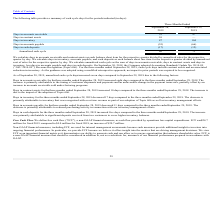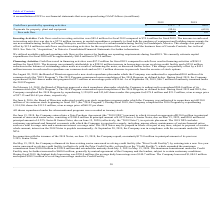According to Plexus's financial document, How was Free Cash Flow defined by the company? as cash flow provided by operations less capital expenditures. The document states: "cash flow ("FCF"), a non-GAAP financial measure, as cash flow provided by operations less capital expenditures. FCF was $24.7 million for fiscal 2019 ..." Also, What was the free cash flow in 2018? According to the financial document, 4.0 (in millions). The relevant text states: "Free cash flow $ 24.7 $ 4.0..." Also, Which years does the table provide information for the company's free cash flows? The document shows two values: 2019 and 2018. From the document: "2019 2018 2019 2018..." Also, How many years did cash flows provided by operating activities exceed $100 million? Based on the analysis, there are 1 instances. The counting process: 2019. Also, can you calculate: What was the change in Payments for property, plant and equipment between 2018 and 2019? Based on the calculation: -90.6-(-62.8), the result is -27.8 (in millions). This is based on the information: "Payments for property, plant and equipment (90.6) (62.8) ayments for property, plant and equipment (90.6) (62.8)..." The key data points involved are: 62.8, 90.6. Also, can you calculate: What was the percentage change in the free cash flow between 2018 and 2019? To answer this question, I need to perform calculations using the financial data. The calculation is: (24.7-4.0)/4.0, which equals 517.5 (percentage). This is based on the information: "Free cash flow $ 24.7 $ 4.0 Free cash flow $ 24.7 $ 4.0..." The key data points involved are: 24.7, 4.0. 